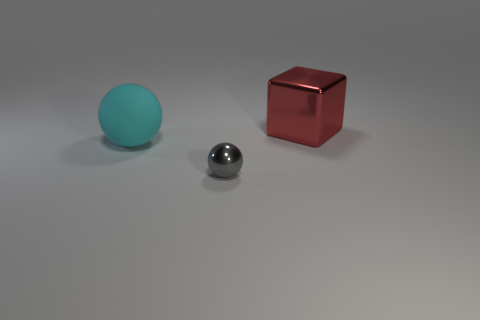What number of matte things are behind the ball that is in front of the large object left of the gray object?
Offer a very short reply. 1. Does the rubber sphere have the same size as the shiny thing right of the tiny ball?
Provide a short and direct response. Yes. What is the size of the sphere that is to the left of the metallic object in front of the large cyan matte object?
Your response must be concise. Large. How many gray spheres have the same material as the big red thing?
Your answer should be compact. 1. Are there any big gray rubber things?
Offer a terse response. No. How big is the metal thing that is to the left of the big red object?
Make the answer very short. Small. What number of large things are the same color as the metallic block?
Provide a short and direct response. 0. What number of balls are large things or small gray objects?
Make the answer very short. 2. The object that is both on the right side of the cyan rubber object and in front of the red block has what shape?
Keep it short and to the point. Sphere. Are there any cyan rubber balls of the same size as the rubber thing?
Your answer should be compact. No. 